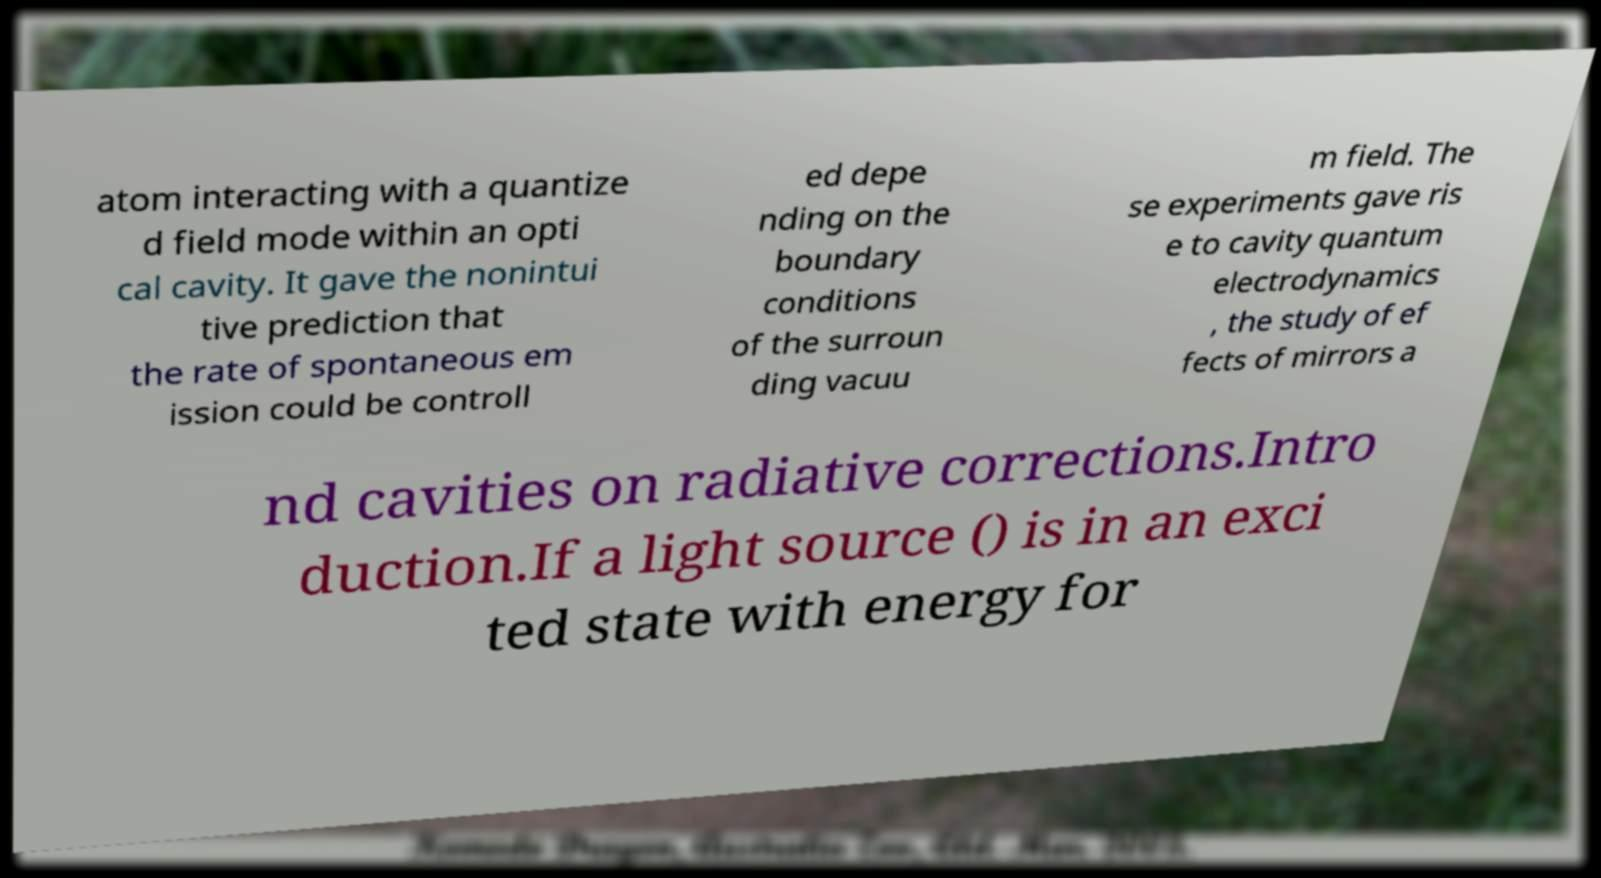Could you extract and type out the text from this image? atom interacting with a quantize d field mode within an opti cal cavity. It gave the nonintui tive prediction that the rate of spontaneous em ission could be controll ed depe nding on the boundary conditions of the surroun ding vacuu m field. The se experiments gave ris e to cavity quantum electrodynamics , the study of ef fects of mirrors a nd cavities on radiative corrections.Intro duction.If a light source () is in an exci ted state with energy for 